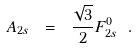<formula> <loc_0><loc_0><loc_500><loc_500>A _ { 2 s } \ = \ \frac { \sqrt { 3 } } 2 F ^ { 0 } _ { 2 s } \ .</formula> 